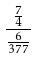Convert formula to latex. <formula><loc_0><loc_0><loc_500><loc_500>\frac { \frac { 7 } { 4 } } { \frac { 6 } { 3 7 7 } }</formula> 